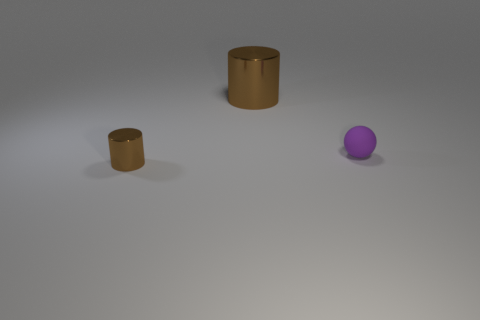Add 3 tiny brown shiny objects. How many objects exist? 6 Subtract all cylinders. How many objects are left? 1 Subtract all red cubes. How many green cylinders are left? 0 Subtract all cyan cylinders. Subtract all small rubber spheres. How many objects are left? 2 Add 2 brown cylinders. How many brown cylinders are left? 4 Add 2 big yellow metal blocks. How many big yellow metal blocks exist? 2 Subtract 0 red spheres. How many objects are left? 3 Subtract 2 cylinders. How many cylinders are left? 0 Subtract all red cylinders. Subtract all red spheres. How many cylinders are left? 2 